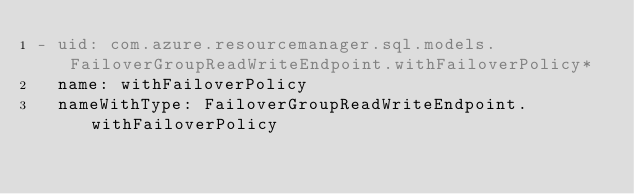<code> <loc_0><loc_0><loc_500><loc_500><_YAML_>- uid: com.azure.resourcemanager.sql.models.FailoverGroupReadWriteEndpoint.withFailoverPolicy*
  name: withFailoverPolicy
  nameWithType: FailoverGroupReadWriteEndpoint.withFailoverPolicy</code> 